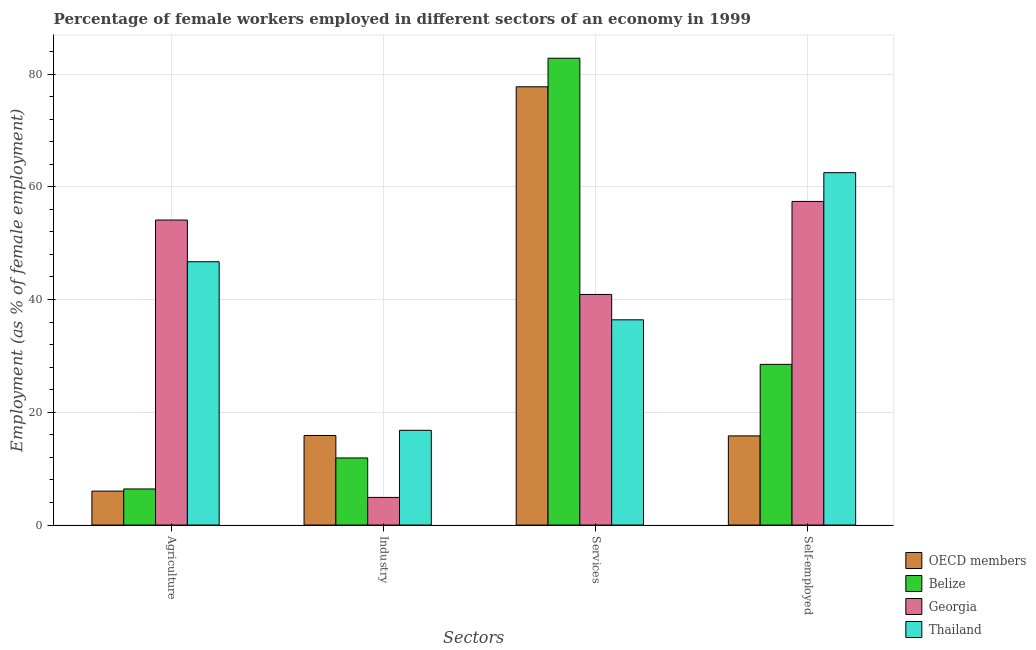How many groups of bars are there?
Provide a short and direct response. 4. How many bars are there on the 4th tick from the right?
Your answer should be compact. 4. What is the label of the 2nd group of bars from the left?
Your answer should be very brief. Industry. What is the percentage of female workers in industry in Thailand?
Make the answer very short. 16.8. Across all countries, what is the maximum percentage of self employed female workers?
Give a very brief answer. 62.5. Across all countries, what is the minimum percentage of self employed female workers?
Your answer should be very brief. 15.82. In which country was the percentage of self employed female workers maximum?
Ensure brevity in your answer.  Thailand. In which country was the percentage of female workers in agriculture minimum?
Keep it short and to the point. OECD members. What is the total percentage of female workers in agriculture in the graph?
Provide a succinct answer. 113.22. What is the difference between the percentage of female workers in industry in Georgia and that in Thailand?
Provide a short and direct response. -11.9. What is the difference between the percentage of female workers in agriculture in OECD members and the percentage of self employed female workers in Thailand?
Provide a short and direct response. -56.48. What is the average percentage of female workers in industry per country?
Ensure brevity in your answer.  12.37. What is the difference between the percentage of self employed female workers and percentage of female workers in industry in Belize?
Your answer should be very brief. 16.6. In how many countries, is the percentage of female workers in industry greater than 60 %?
Provide a short and direct response. 0. What is the ratio of the percentage of self employed female workers in Belize to that in Thailand?
Ensure brevity in your answer.  0.46. Is the percentage of female workers in industry in Belize less than that in Thailand?
Give a very brief answer. Yes. What is the difference between the highest and the second highest percentage of female workers in services?
Make the answer very short. 5.07. What is the difference between the highest and the lowest percentage of self employed female workers?
Make the answer very short. 46.68. In how many countries, is the percentage of female workers in agriculture greater than the average percentage of female workers in agriculture taken over all countries?
Offer a terse response. 2. Is the sum of the percentage of self employed female workers in Thailand and OECD members greater than the maximum percentage of female workers in industry across all countries?
Offer a very short reply. Yes. Is it the case that in every country, the sum of the percentage of female workers in agriculture and percentage of female workers in industry is greater than the sum of percentage of female workers in services and percentage of self employed female workers?
Your answer should be very brief. No. What does the 4th bar from the left in Agriculture represents?
Provide a short and direct response. Thailand. What does the 1st bar from the right in Industry represents?
Your answer should be very brief. Thailand. Is it the case that in every country, the sum of the percentage of female workers in agriculture and percentage of female workers in industry is greater than the percentage of female workers in services?
Ensure brevity in your answer.  No. Are all the bars in the graph horizontal?
Your response must be concise. No. How many countries are there in the graph?
Your response must be concise. 4. What is the difference between two consecutive major ticks on the Y-axis?
Provide a succinct answer. 20. Does the graph contain any zero values?
Ensure brevity in your answer.  No. Where does the legend appear in the graph?
Offer a terse response. Bottom right. How are the legend labels stacked?
Offer a terse response. Vertical. What is the title of the graph?
Provide a short and direct response. Percentage of female workers employed in different sectors of an economy in 1999. Does "India" appear as one of the legend labels in the graph?
Your answer should be compact. No. What is the label or title of the X-axis?
Provide a succinct answer. Sectors. What is the label or title of the Y-axis?
Offer a very short reply. Employment (as % of female employment). What is the Employment (as % of female employment) in OECD members in Agriculture?
Offer a terse response. 6.02. What is the Employment (as % of female employment) of Belize in Agriculture?
Your answer should be compact. 6.4. What is the Employment (as % of female employment) of Georgia in Agriculture?
Your answer should be compact. 54.1. What is the Employment (as % of female employment) of Thailand in Agriculture?
Your response must be concise. 46.7. What is the Employment (as % of female employment) of OECD members in Industry?
Keep it short and to the point. 15.89. What is the Employment (as % of female employment) of Belize in Industry?
Provide a succinct answer. 11.9. What is the Employment (as % of female employment) in Georgia in Industry?
Make the answer very short. 4.9. What is the Employment (as % of female employment) in Thailand in Industry?
Your response must be concise. 16.8. What is the Employment (as % of female employment) in OECD members in Services?
Offer a very short reply. 77.73. What is the Employment (as % of female employment) of Belize in Services?
Keep it short and to the point. 82.8. What is the Employment (as % of female employment) in Georgia in Services?
Your response must be concise. 40.9. What is the Employment (as % of female employment) of Thailand in Services?
Your response must be concise. 36.4. What is the Employment (as % of female employment) of OECD members in Self-employed?
Provide a short and direct response. 15.82. What is the Employment (as % of female employment) of Georgia in Self-employed?
Provide a short and direct response. 57.4. What is the Employment (as % of female employment) of Thailand in Self-employed?
Give a very brief answer. 62.5. Across all Sectors, what is the maximum Employment (as % of female employment) in OECD members?
Make the answer very short. 77.73. Across all Sectors, what is the maximum Employment (as % of female employment) in Belize?
Make the answer very short. 82.8. Across all Sectors, what is the maximum Employment (as % of female employment) of Georgia?
Provide a succinct answer. 57.4. Across all Sectors, what is the maximum Employment (as % of female employment) of Thailand?
Give a very brief answer. 62.5. Across all Sectors, what is the minimum Employment (as % of female employment) of OECD members?
Your answer should be very brief. 6.02. Across all Sectors, what is the minimum Employment (as % of female employment) in Belize?
Provide a succinct answer. 6.4. Across all Sectors, what is the minimum Employment (as % of female employment) in Georgia?
Ensure brevity in your answer.  4.9. Across all Sectors, what is the minimum Employment (as % of female employment) of Thailand?
Offer a terse response. 16.8. What is the total Employment (as % of female employment) of OECD members in the graph?
Provide a succinct answer. 115.45. What is the total Employment (as % of female employment) of Belize in the graph?
Ensure brevity in your answer.  129.6. What is the total Employment (as % of female employment) in Georgia in the graph?
Make the answer very short. 157.3. What is the total Employment (as % of female employment) of Thailand in the graph?
Your answer should be very brief. 162.4. What is the difference between the Employment (as % of female employment) in OECD members in Agriculture and that in Industry?
Your answer should be very brief. -9.87. What is the difference between the Employment (as % of female employment) in Georgia in Agriculture and that in Industry?
Offer a terse response. 49.2. What is the difference between the Employment (as % of female employment) of Thailand in Agriculture and that in Industry?
Offer a terse response. 29.9. What is the difference between the Employment (as % of female employment) of OECD members in Agriculture and that in Services?
Your answer should be compact. -71.71. What is the difference between the Employment (as % of female employment) of Belize in Agriculture and that in Services?
Keep it short and to the point. -76.4. What is the difference between the Employment (as % of female employment) of Georgia in Agriculture and that in Services?
Offer a very short reply. 13.2. What is the difference between the Employment (as % of female employment) of Thailand in Agriculture and that in Services?
Offer a very short reply. 10.3. What is the difference between the Employment (as % of female employment) in OECD members in Agriculture and that in Self-employed?
Make the answer very short. -9.8. What is the difference between the Employment (as % of female employment) in Belize in Agriculture and that in Self-employed?
Give a very brief answer. -22.1. What is the difference between the Employment (as % of female employment) of Thailand in Agriculture and that in Self-employed?
Provide a short and direct response. -15.8. What is the difference between the Employment (as % of female employment) in OECD members in Industry and that in Services?
Provide a succinct answer. -61.84. What is the difference between the Employment (as % of female employment) of Belize in Industry and that in Services?
Ensure brevity in your answer.  -70.9. What is the difference between the Employment (as % of female employment) in Georgia in Industry and that in Services?
Offer a terse response. -36. What is the difference between the Employment (as % of female employment) in Thailand in Industry and that in Services?
Provide a succinct answer. -19.6. What is the difference between the Employment (as % of female employment) in OECD members in Industry and that in Self-employed?
Keep it short and to the point. 0.07. What is the difference between the Employment (as % of female employment) in Belize in Industry and that in Self-employed?
Your answer should be compact. -16.6. What is the difference between the Employment (as % of female employment) of Georgia in Industry and that in Self-employed?
Your answer should be compact. -52.5. What is the difference between the Employment (as % of female employment) of Thailand in Industry and that in Self-employed?
Your answer should be compact. -45.7. What is the difference between the Employment (as % of female employment) in OECD members in Services and that in Self-employed?
Make the answer very short. 61.92. What is the difference between the Employment (as % of female employment) of Belize in Services and that in Self-employed?
Offer a very short reply. 54.3. What is the difference between the Employment (as % of female employment) in Georgia in Services and that in Self-employed?
Provide a short and direct response. -16.5. What is the difference between the Employment (as % of female employment) of Thailand in Services and that in Self-employed?
Give a very brief answer. -26.1. What is the difference between the Employment (as % of female employment) in OECD members in Agriculture and the Employment (as % of female employment) in Belize in Industry?
Give a very brief answer. -5.88. What is the difference between the Employment (as % of female employment) of OECD members in Agriculture and the Employment (as % of female employment) of Georgia in Industry?
Your response must be concise. 1.12. What is the difference between the Employment (as % of female employment) of OECD members in Agriculture and the Employment (as % of female employment) of Thailand in Industry?
Offer a very short reply. -10.78. What is the difference between the Employment (as % of female employment) of Belize in Agriculture and the Employment (as % of female employment) of Georgia in Industry?
Your answer should be very brief. 1.5. What is the difference between the Employment (as % of female employment) in Belize in Agriculture and the Employment (as % of female employment) in Thailand in Industry?
Provide a short and direct response. -10.4. What is the difference between the Employment (as % of female employment) of Georgia in Agriculture and the Employment (as % of female employment) of Thailand in Industry?
Provide a succinct answer. 37.3. What is the difference between the Employment (as % of female employment) in OECD members in Agriculture and the Employment (as % of female employment) in Belize in Services?
Provide a succinct answer. -76.78. What is the difference between the Employment (as % of female employment) of OECD members in Agriculture and the Employment (as % of female employment) of Georgia in Services?
Offer a terse response. -34.88. What is the difference between the Employment (as % of female employment) in OECD members in Agriculture and the Employment (as % of female employment) in Thailand in Services?
Your answer should be very brief. -30.38. What is the difference between the Employment (as % of female employment) in Belize in Agriculture and the Employment (as % of female employment) in Georgia in Services?
Your answer should be compact. -34.5. What is the difference between the Employment (as % of female employment) in Belize in Agriculture and the Employment (as % of female employment) in Thailand in Services?
Your answer should be compact. -30. What is the difference between the Employment (as % of female employment) in Georgia in Agriculture and the Employment (as % of female employment) in Thailand in Services?
Offer a very short reply. 17.7. What is the difference between the Employment (as % of female employment) of OECD members in Agriculture and the Employment (as % of female employment) of Belize in Self-employed?
Offer a very short reply. -22.48. What is the difference between the Employment (as % of female employment) in OECD members in Agriculture and the Employment (as % of female employment) in Georgia in Self-employed?
Offer a very short reply. -51.38. What is the difference between the Employment (as % of female employment) of OECD members in Agriculture and the Employment (as % of female employment) of Thailand in Self-employed?
Keep it short and to the point. -56.48. What is the difference between the Employment (as % of female employment) of Belize in Agriculture and the Employment (as % of female employment) of Georgia in Self-employed?
Ensure brevity in your answer.  -51. What is the difference between the Employment (as % of female employment) in Belize in Agriculture and the Employment (as % of female employment) in Thailand in Self-employed?
Ensure brevity in your answer.  -56.1. What is the difference between the Employment (as % of female employment) in Georgia in Agriculture and the Employment (as % of female employment) in Thailand in Self-employed?
Give a very brief answer. -8.4. What is the difference between the Employment (as % of female employment) of OECD members in Industry and the Employment (as % of female employment) of Belize in Services?
Your answer should be compact. -66.91. What is the difference between the Employment (as % of female employment) of OECD members in Industry and the Employment (as % of female employment) of Georgia in Services?
Ensure brevity in your answer.  -25.01. What is the difference between the Employment (as % of female employment) in OECD members in Industry and the Employment (as % of female employment) in Thailand in Services?
Provide a succinct answer. -20.51. What is the difference between the Employment (as % of female employment) in Belize in Industry and the Employment (as % of female employment) in Georgia in Services?
Offer a very short reply. -29. What is the difference between the Employment (as % of female employment) of Belize in Industry and the Employment (as % of female employment) of Thailand in Services?
Offer a terse response. -24.5. What is the difference between the Employment (as % of female employment) of Georgia in Industry and the Employment (as % of female employment) of Thailand in Services?
Ensure brevity in your answer.  -31.5. What is the difference between the Employment (as % of female employment) of OECD members in Industry and the Employment (as % of female employment) of Belize in Self-employed?
Provide a succinct answer. -12.61. What is the difference between the Employment (as % of female employment) in OECD members in Industry and the Employment (as % of female employment) in Georgia in Self-employed?
Your answer should be compact. -41.51. What is the difference between the Employment (as % of female employment) of OECD members in Industry and the Employment (as % of female employment) of Thailand in Self-employed?
Provide a short and direct response. -46.61. What is the difference between the Employment (as % of female employment) of Belize in Industry and the Employment (as % of female employment) of Georgia in Self-employed?
Your answer should be compact. -45.5. What is the difference between the Employment (as % of female employment) of Belize in Industry and the Employment (as % of female employment) of Thailand in Self-employed?
Provide a short and direct response. -50.6. What is the difference between the Employment (as % of female employment) of Georgia in Industry and the Employment (as % of female employment) of Thailand in Self-employed?
Your answer should be very brief. -57.6. What is the difference between the Employment (as % of female employment) of OECD members in Services and the Employment (as % of female employment) of Belize in Self-employed?
Offer a terse response. 49.23. What is the difference between the Employment (as % of female employment) of OECD members in Services and the Employment (as % of female employment) of Georgia in Self-employed?
Provide a succinct answer. 20.33. What is the difference between the Employment (as % of female employment) of OECD members in Services and the Employment (as % of female employment) of Thailand in Self-employed?
Your response must be concise. 15.23. What is the difference between the Employment (as % of female employment) of Belize in Services and the Employment (as % of female employment) of Georgia in Self-employed?
Your response must be concise. 25.4. What is the difference between the Employment (as % of female employment) in Belize in Services and the Employment (as % of female employment) in Thailand in Self-employed?
Provide a short and direct response. 20.3. What is the difference between the Employment (as % of female employment) in Georgia in Services and the Employment (as % of female employment) in Thailand in Self-employed?
Your answer should be compact. -21.6. What is the average Employment (as % of female employment) of OECD members per Sectors?
Your answer should be compact. 28.86. What is the average Employment (as % of female employment) of Belize per Sectors?
Offer a very short reply. 32.4. What is the average Employment (as % of female employment) of Georgia per Sectors?
Make the answer very short. 39.33. What is the average Employment (as % of female employment) of Thailand per Sectors?
Your answer should be very brief. 40.6. What is the difference between the Employment (as % of female employment) in OECD members and Employment (as % of female employment) in Belize in Agriculture?
Your answer should be very brief. -0.38. What is the difference between the Employment (as % of female employment) of OECD members and Employment (as % of female employment) of Georgia in Agriculture?
Keep it short and to the point. -48.08. What is the difference between the Employment (as % of female employment) of OECD members and Employment (as % of female employment) of Thailand in Agriculture?
Keep it short and to the point. -40.68. What is the difference between the Employment (as % of female employment) of Belize and Employment (as % of female employment) of Georgia in Agriculture?
Keep it short and to the point. -47.7. What is the difference between the Employment (as % of female employment) of Belize and Employment (as % of female employment) of Thailand in Agriculture?
Give a very brief answer. -40.3. What is the difference between the Employment (as % of female employment) of OECD members and Employment (as % of female employment) of Belize in Industry?
Keep it short and to the point. 3.99. What is the difference between the Employment (as % of female employment) in OECD members and Employment (as % of female employment) in Georgia in Industry?
Provide a succinct answer. 10.99. What is the difference between the Employment (as % of female employment) of OECD members and Employment (as % of female employment) of Thailand in Industry?
Keep it short and to the point. -0.91. What is the difference between the Employment (as % of female employment) in Belize and Employment (as % of female employment) in Georgia in Industry?
Offer a terse response. 7. What is the difference between the Employment (as % of female employment) in OECD members and Employment (as % of female employment) in Belize in Services?
Provide a succinct answer. -5.07. What is the difference between the Employment (as % of female employment) of OECD members and Employment (as % of female employment) of Georgia in Services?
Make the answer very short. 36.83. What is the difference between the Employment (as % of female employment) of OECD members and Employment (as % of female employment) of Thailand in Services?
Your answer should be very brief. 41.33. What is the difference between the Employment (as % of female employment) of Belize and Employment (as % of female employment) of Georgia in Services?
Keep it short and to the point. 41.9. What is the difference between the Employment (as % of female employment) of Belize and Employment (as % of female employment) of Thailand in Services?
Keep it short and to the point. 46.4. What is the difference between the Employment (as % of female employment) of Georgia and Employment (as % of female employment) of Thailand in Services?
Make the answer very short. 4.5. What is the difference between the Employment (as % of female employment) in OECD members and Employment (as % of female employment) in Belize in Self-employed?
Offer a terse response. -12.69. What is the difference between the Employment (as % of female employment) of OECD members and Employment (as % of female employment) of Georgia in Self-employed?
Give a very brief answer. -41.59. What is the difference between the Employment (as % of female employment) of OECD members and Employment (as % of female employment) of Thailand in Self-employed?
Your answer should be very brief. -46.69. What is the difference between the Employment (as % of female employment) of Belize and Employment (as % of female employment) of Georgia in Self-employed?
Give a very brief answer. -28.9. What is the difference between the Employment (as % of female employment) in Belize and Employment (as % of female employment) in Thailand in Self-employed?
Provide a succinct answer. -34. What is the ratio of the Employment (as % of female employment) of OECD members in Agriculture to that in Industry?
Offer a terse response. 0.38. What is the ratio of the Employment (as % of female employment) in Belize in Agriculture to that in Industry?
Your answer should be compact. 0.54. What is the ratio of the Employment (as % of female employment) in Georgia in Agriculture to that in Industry?
Your answer should be very brief. 11.04. What is the ratio of the Employment (as % of female employment) in Thailand in Agriculture to that in Industry?
Make the answer very short. 2.78. What is the ratio of the Employment (as % of female employment) in OECD members in Agriculture to that in Services?
Offer a terse response. 0.08. What is the ratio of the Employment (as % of female employment) in Belize in Agriculture to that in Services?
Provide a succinct answer. 0.08. What is the ratio of the Employment (as % of female employment) in Georgia in Agriculture to that in Services?
Keep it short and to the point. 1.32. What is the ratio of the Employment (as % of female employment) in Thailand in Agriculture to that in Services?
Your answer should be very brief. 1.28. What is the ratio of the Employment (as % of female employment) of OECD members in Agriculture to that in Self-employed?
Offer a terse response. 0.38. What is the ratio of the Employment (as % of female employment) in Belize in Agriculture to that in Self-employed?
Offer a very short reply. 0.22. What is the ratio of the Employment (as % of female employment) in Georgia in Agriculture to that in Self-employed?
Provide a short and direct response. 0.94. What is the ratio of the Employment (as % of female employment) in Thailand in Agriculture to that in Self-employed?
Give a very brief answer. 0.75. What is the ratio of the Employment (as % of female employment) of OECD members in Industry to that in Services?
Your answer should be very brief. 0.2. What is the ratio of the Employment (as % of female employment) of Belize in Industry to that in Services?
Offer a terse response. 0.14. What is the ratio of the Employment (as % of female employment) in Georgia in Industry to that in Services?
Offer a terse response. 0.12. What is the ratio of the Employment (as % of female employment) of Thailand in Industry to that in Services?
Ensure brevity in your answer.  0.46. What is the ratio of the Employment (as % of female employment) of Belize in Industry to that in Self-employed?
Offer a terse response. 0.42. What is the ratio of the Employment (as % of female employment) in Georgia in Industry to that in Self-employed?
Give a very brief answer. 0.09. What is the ratio of the Employment (as % of female employment) in Thailand in Industry to that in Self-employed?
Give a very brief answer. 0.27. What is the ratio of the Employment (as % of female employment) of OECD members in Services to that in Self-employed?
Your answer should be very brief. 4.92. What is the ratio of the Employment (as % of female employment) in Belize in Services to that in Self-employed?
Your answer should be compact. 2.91. What is the ratio of the Employment (as % of female employment) of Georgia in Services to that in Self-employed?
Keep it short and to the point. 0.71. What is the ratio of the Employment (as % of female employment) in Thailand in Services to that in Self-employed?
Your response must be concise. 0.58. What is the difference between the highest and the second highest Employment (as % of female employment) of OECD members?
Provide a short and direct response. 61.84. What is the difference between the highest and the second highest Employment (as % of female employment) in Belize?
Ensure brevity in your answer.  54.3. What is the difference between the highest and the second highest Employment (as % of female employment) in Thailand?
Ensure brevity in your answer.  15.8. What is the difference between the highest and the lowest Employment (as % of female employment) of OECD members?
Provide a short and direct response. 71.71. What is the difference between the highest and the lowest Employment (as % of female employment) in Belize?
Your response must be concise. 76.4. What is the difference between the highest and the lowest Employment (as % of female employment) in Georgia?
Give a very brief answer. 52.5. What is the difference between the highest and the lowest Employment (as % of female employment) of Thailand?
Offer a terse response. 45.7. 